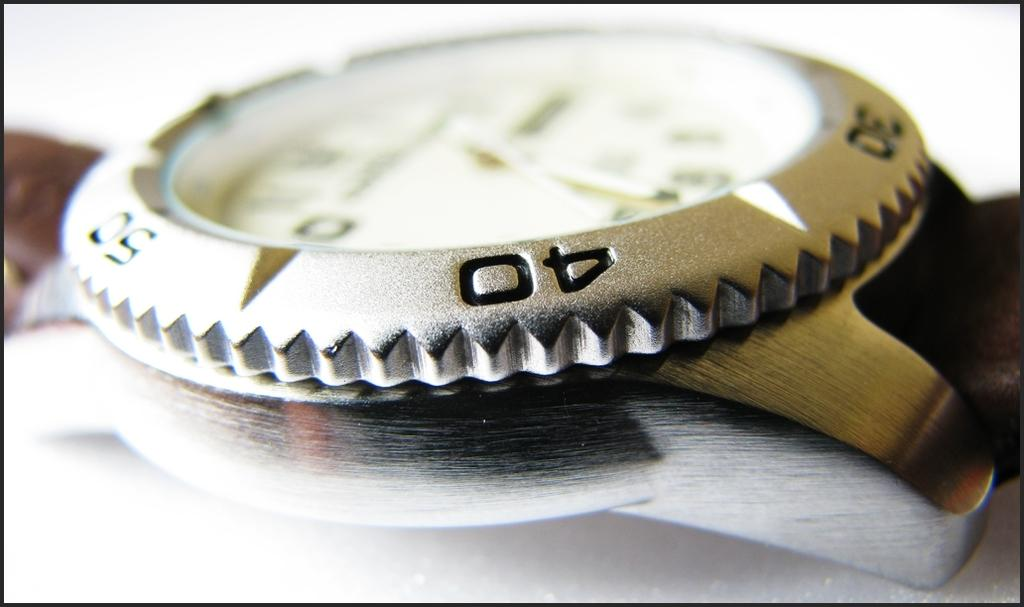Provide a one-sentence caption for the provided image. An analog watch surrounde by 30, 40 and 50 in the metal around it, on a brown band. 